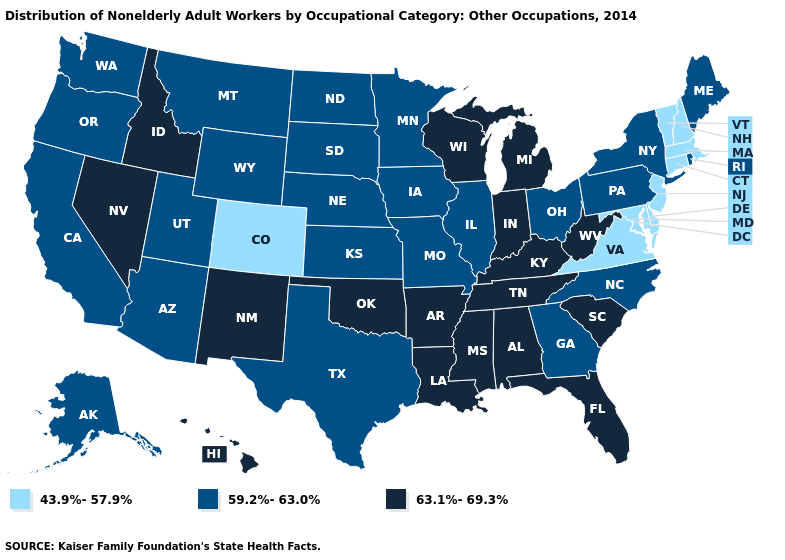What is the lowest value in the South?
Answer briefly. 43.9%-57.9%. Which states have the lowest value in the USA?
Quick response, please. Colorado, Connecticut, Delaware, Maryland, Massachusetts, New Hampshire, New Jersey, Vermont, Virginia. Which states have the highest value in the USA?
Be succinct. Alabama, Arkansas, Florida, Hawaii, Idaho, Indiana, Kentucky, Louisiana, Michigan, Mississippi, Nevada, New Mexico, Oklahoma, South Carolina, Tennessee, West Virginia, Wisconsin. Which states have the lowest value in the MidWest?
Give a very brief answer. Illinois, Iowa, Kansas, Minnesota, Missouri, Nebraska, North Dakota, Ohio, South Dakota. Is the legend a continuous bar?
Concise answer only. No. What is the highest value in the MidWest ?
Write a very short answer. 63.1%-69.3%. What is the value of Florida?
Quick response, please. 63.1%-69.3%. Name the states that have a value in the range 43.9%-57.9%?
Be succinct. Colorado, Connecticut, Delaware, Maryland, Massachusetts, New Hampshire, New Jersey, Vermont, Virginia. How many symbols are there in the legend?
Be succinct. 3. Does Wisconsin have a higher value than Rhode Island?
Keep it brief. Yes. Is the legend a continuous bar?
Answer briefly. No. Among the states that border Maryland , does Virginia have the highest value?
Answer briefly. No. What is the value of Wisconsin?
Answer briefly. 63.1%-69.3%. Does Massachusetts have the lowest value in the USA?
Keep it brief. Yes. Does Nebraska have the highest value in the MidWest?
Short answer required. No. 